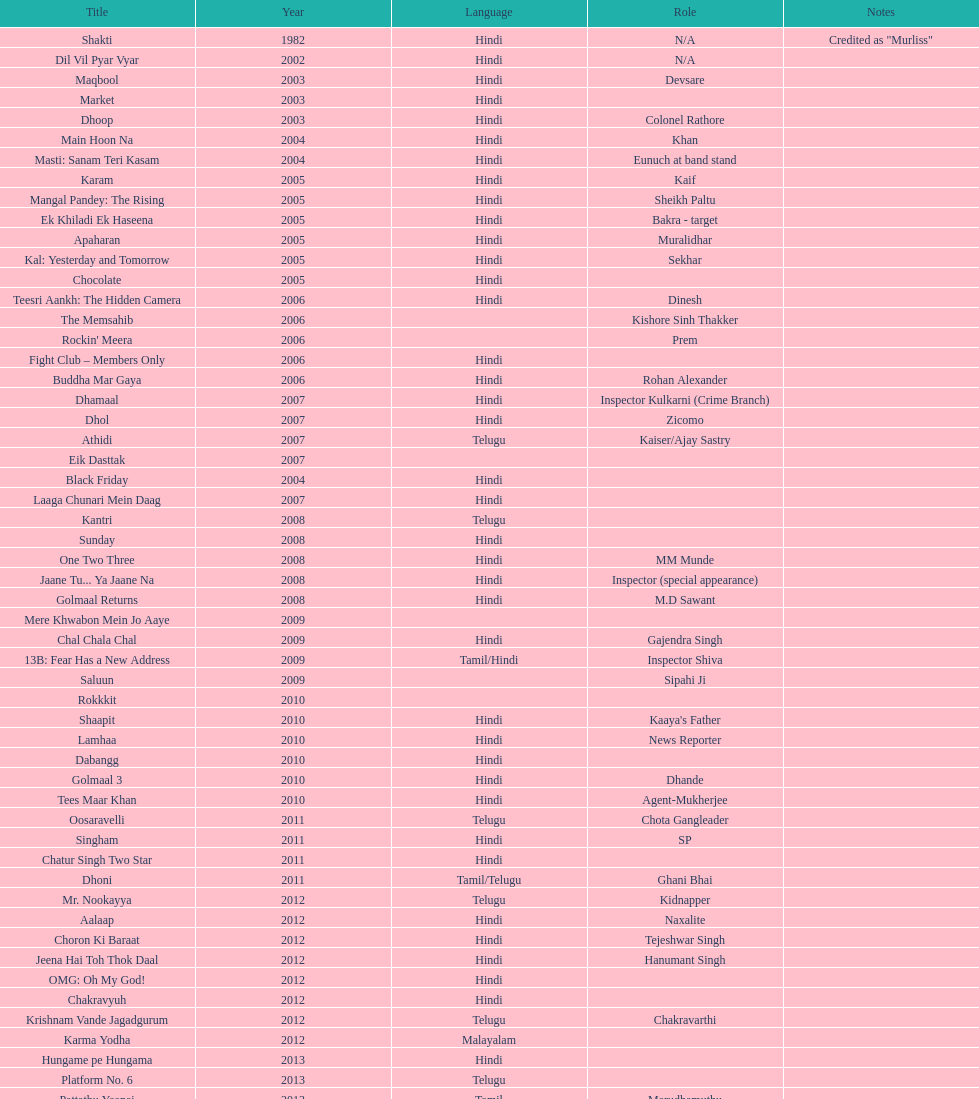In how many different roles has this actor appeared? 36. 